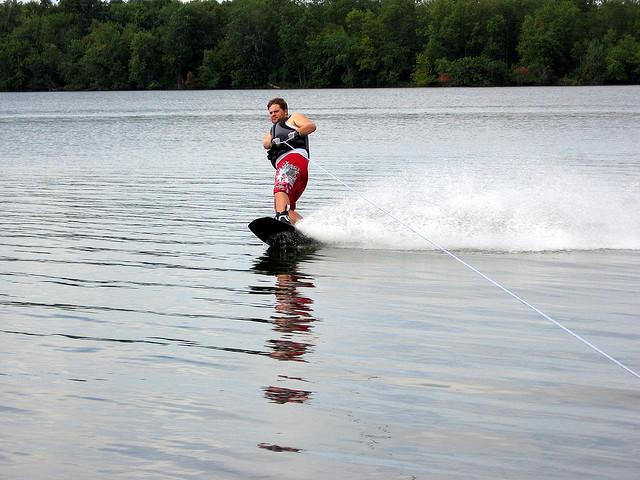What is the person doing?
Be succinct. Water skiing. Where are the trees?
Write a very short answer. Background. What is the boy riding?
Write a very short answer. Board. What sport is this guy doing?
Give a very brief answer. Wakeboarding. What is in the background?
Answer briefly. Trees. Is this person sedentary?
Write a very short answer. No. 